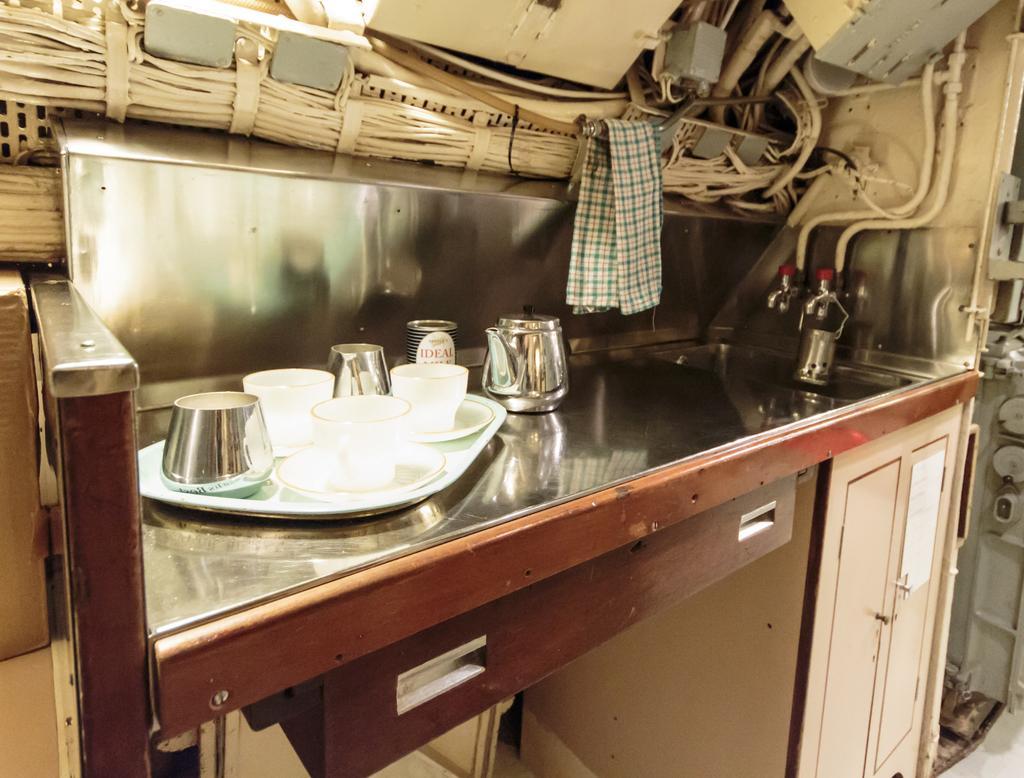Please provide a concise description of this image. In the picture we can see a tray on which we can see cups and saucers are places, we can see kettle, sink, pipes a cloth, wooden cupboard, a few more objects are seen in the picture. 